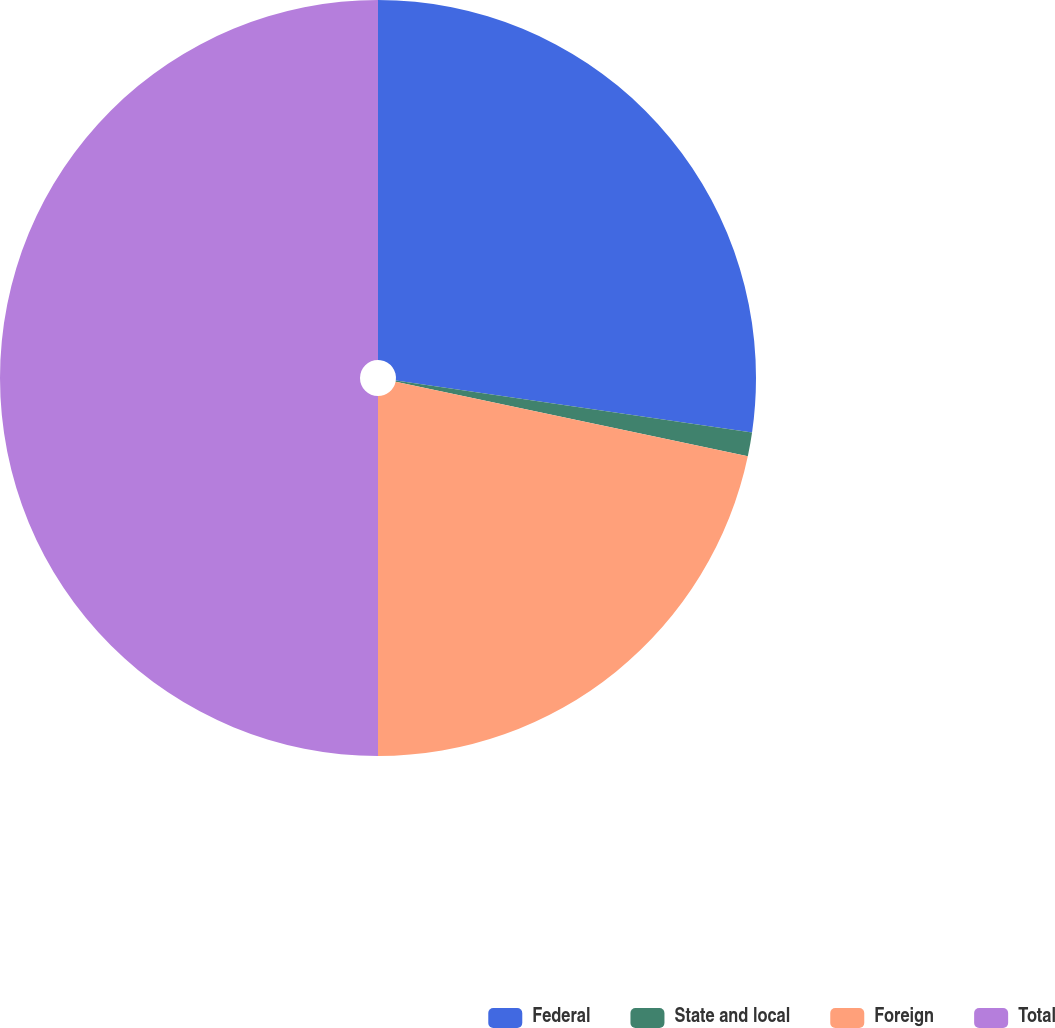Convert chart to OTSL. <chart><loc_0><loc_0><loc_500><loc_500><pie_chart><fcel>Federal<fcel>State and local<fcel>Foreign<fcel>Total<nl><fcel>27.3%<fcel>1.02%<fcel>21.68%<fcel>50.0%<nl></chart> 